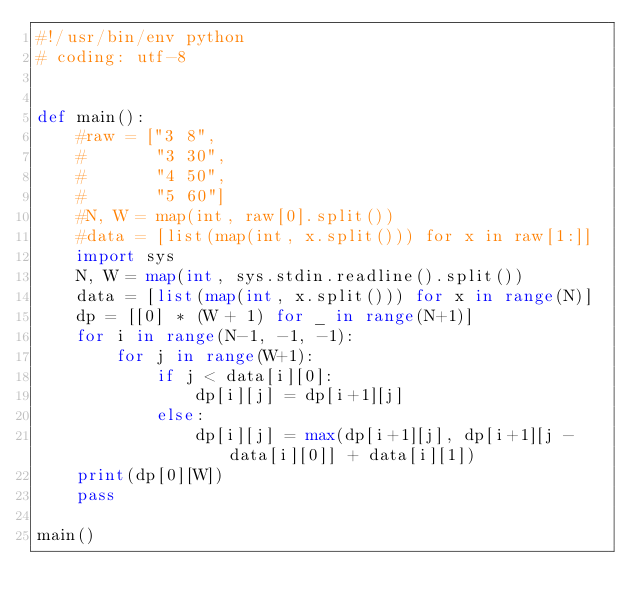Convert code to text. <code><loc_0><loc_0><loc_500><loc_500><_Python_>#!/usr/bin/env python
# coding: utf-8


def main():
    #raw = ["3 8",
    #       "3 30",
    #       "4 50",
    #       "5 60"]
    #N, W = map(int, raw[0].split())
    #data = [list(map(int, x.split())) for x in raw[1:]]
    import sys
    N, W = map(int, sys.stdin.readline().split())
    data = [list(map(int, x.split())) for x in range(N)]
    dp = [[0] * (W + 1) for _ in range(N+1)]
    for i in range(N-1, -1, -1):
        for j in range(W+1):
            if j < data[i][0]:
                dp[i][j] = dp[i+1][j]
            else:
                dp[i][j] = max(dp[i+1][j], dp[i+1][j - data[i][0]] + data[i][1])
    print(dp[0][W])
    pass

main()
</code> 